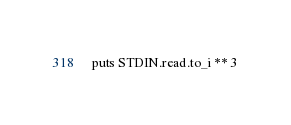<code> <loc_0><loc_0><loc_500><loc_500><_Ruby_>puts STDIN.read.to_i ** 3</code> 